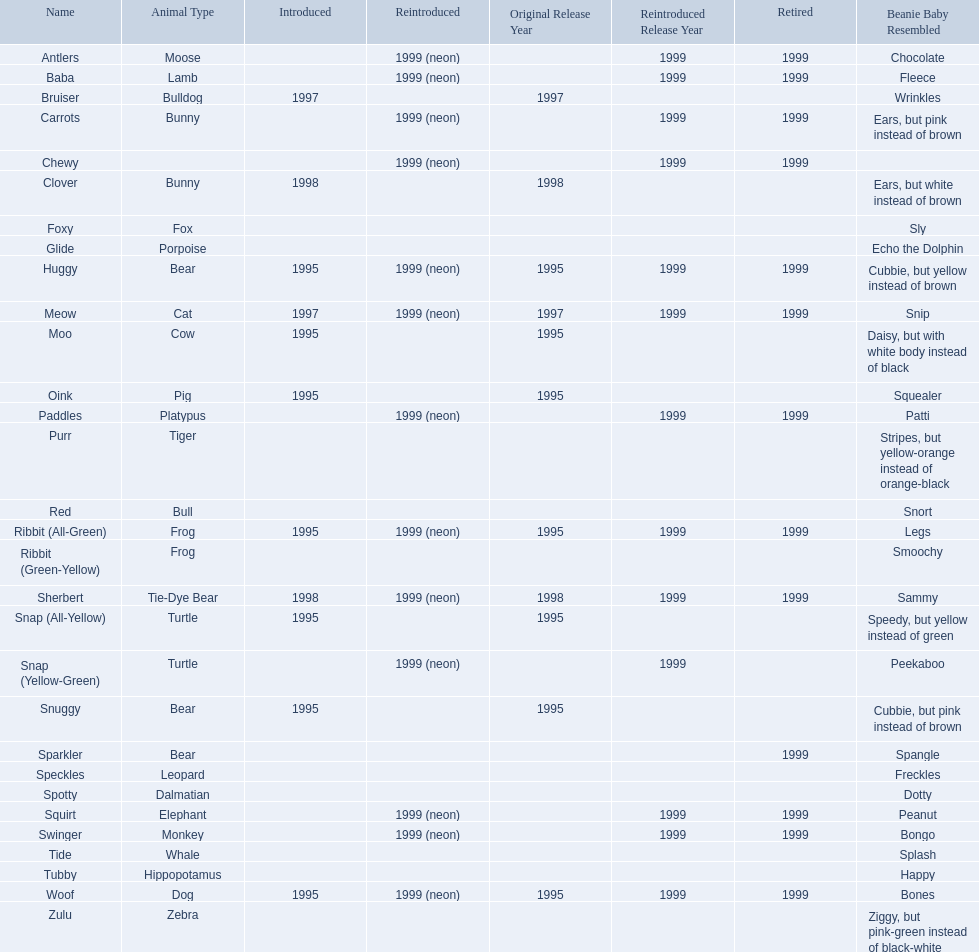Which of the listed pillow pals lack information in at least 3 categories? Chewy, Foxy, Glide, Purr, Red, Ribbit (Green-Yellow), Speckles, Spotty, Tide, Tubby, Zulu. Of those, which one lacks information in the animal type category? Chewy. 